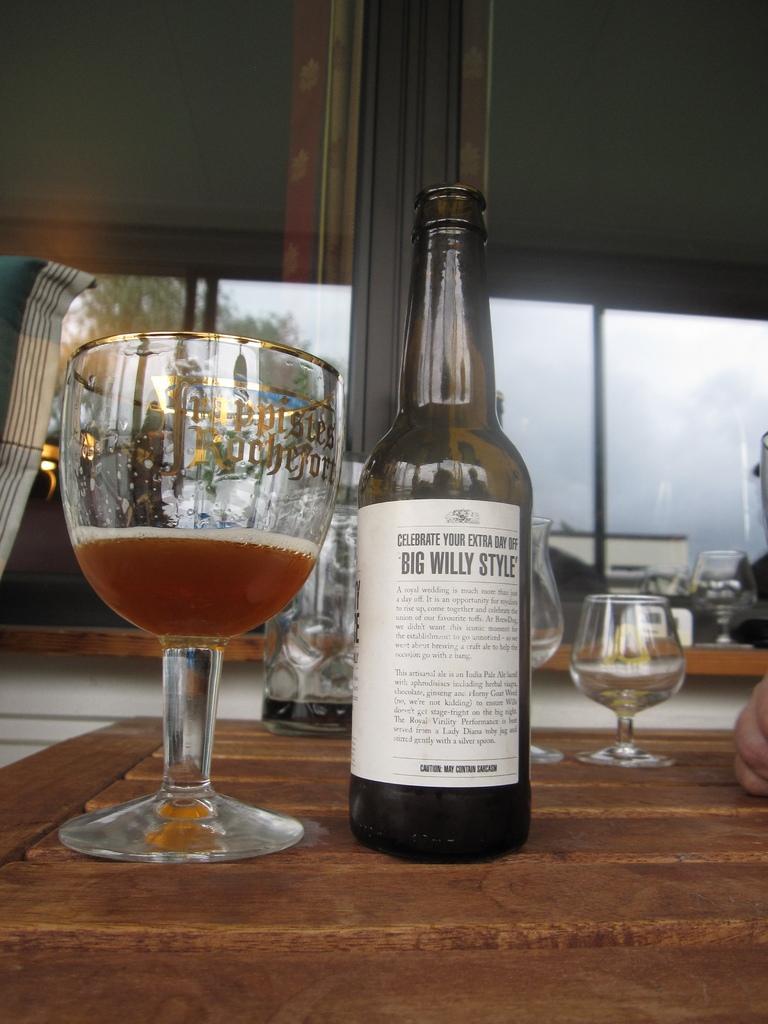Describe this image in one or two sentences. In this picture we can see a bottle with sticker to it and glass with drink in it placed on a wooden platform and in background we can see windows, tree, sky. 